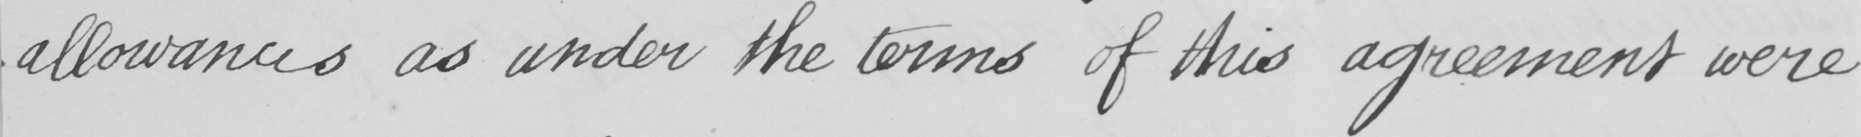What does this handwritten line say? allowances as under the terms of the agreement were 